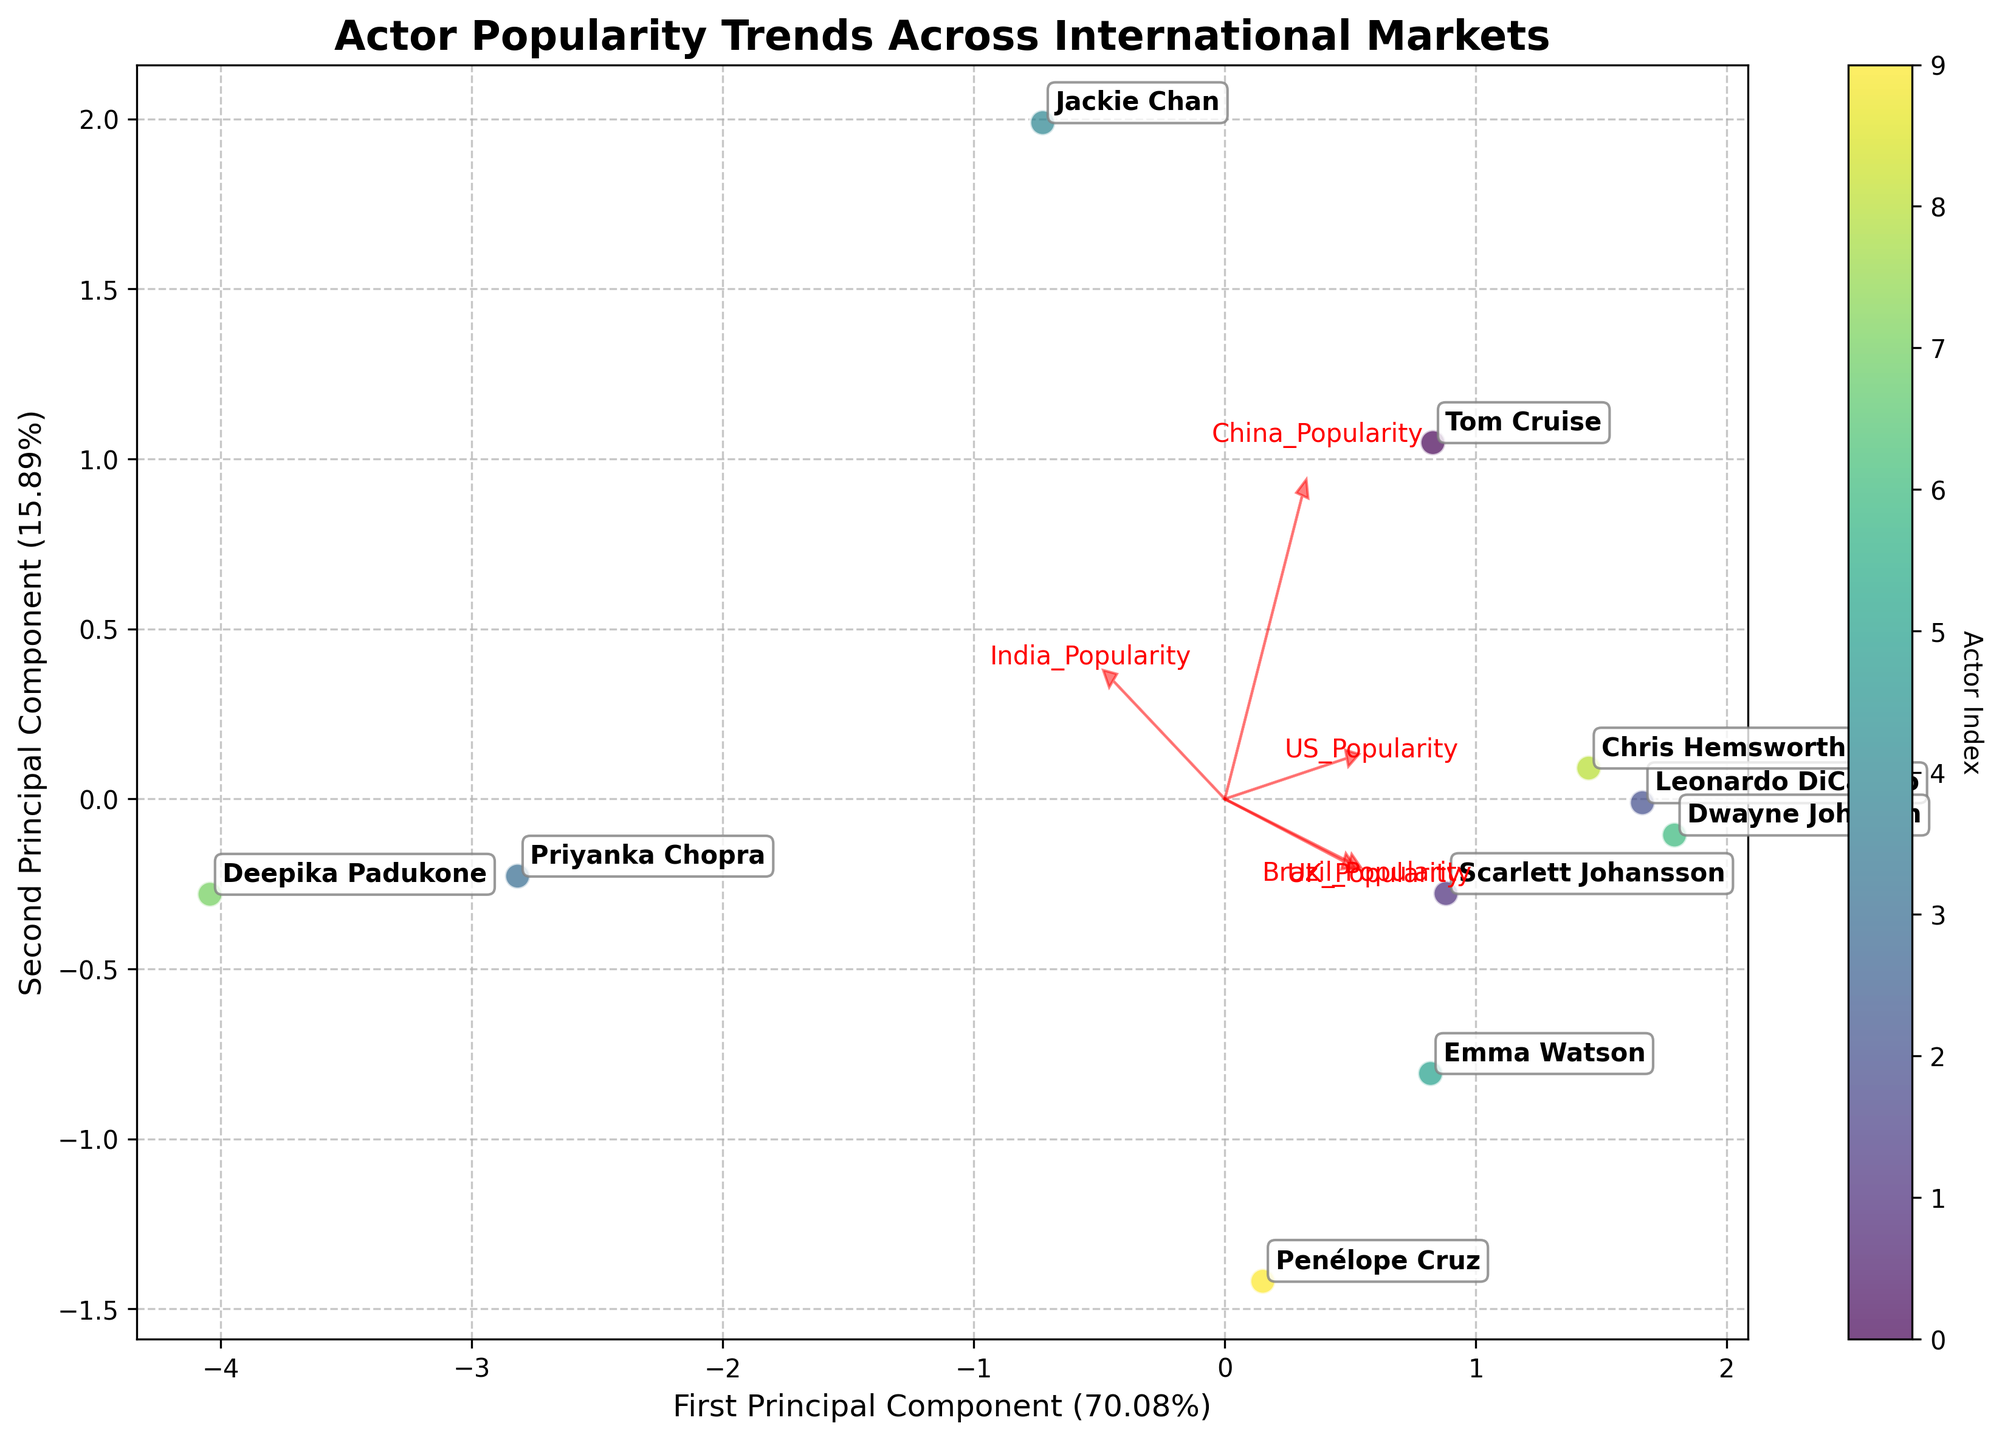What is the title of the plot? The title of the plot is displayed at the top of the figure and reads "Actor Popularity Trends Across International Markets".
Answer: Actor Popularity Trends Across International Markets How many principal components are shown in the biplot? The axes of the plot are labeled as the first and second principal components, which means there are two principal components shown.
Answer: Two Which actor has the highest popularity index in the scatter plot? By looking at the scatter plot, you can see that Dwayne Johnson (indicated by the annotated label) is positioned the furthest to the top-right. This signifies the highest combined score in the first and second principal components.
Answer: Dwayne Johnson Which feature vector is most aligned with the first principal component? The feature vector most aligned with the first principal component is found by looking at which arrow is longest and closest to horizontal. "US_Popularity" appears to be the most aligned with the first principal component.
Answer: US_Popularity How does Priyanka Chopra's popularity in the UK compare to her popularity in China? First, locate Priyanka Chopra in the plot; then, note the direction of the UK's feature vector versus China's feature vector. Priyanka Chopra is closer along the China feature vector in the scatter plot, which indicates her popularity in the China market is higher than in the UK.
Answer: Higher in China What percentage of the total variance is explained by the first principal component? The percentage of variance explained by the first principal component is labeled on the x-axis. It displays a value such as "First Principal Component (X%)", where X is the percentage.
Answer: Around 40% Which actor has the lowest popularity in India? Identify the direction of the India feature vector; the actor closest to the origin in this direction has the lowest popularity. It looks like Penelope Cruz is closest to the origin.
Answer: Penelope Cruz Which two actors are the closest to each other in the plot? Observe the scatter plot and find the two points that are nearest to one another with little distance in between. Emma Watson and Chris Hemsworth are very close to each other, indicating similar popularity patterns.
Answer: Emma Watson and Chris Hemsworth What does the position of the vectors indicate about the relationship between US and UK popularity? The vectors for US and UK popularity are relatively close to each other, suggesting a strong positive correlation between popularity in the US and UK markets.
Answer: Strong positive correlation How much variance is explained by the second principal component? The percentage of variance explained by the second principal component is labeled on the y-axis. It displays a value such as "Second Principal Component (Y%)", where Y is the percentage.
Answer: Around 30% 